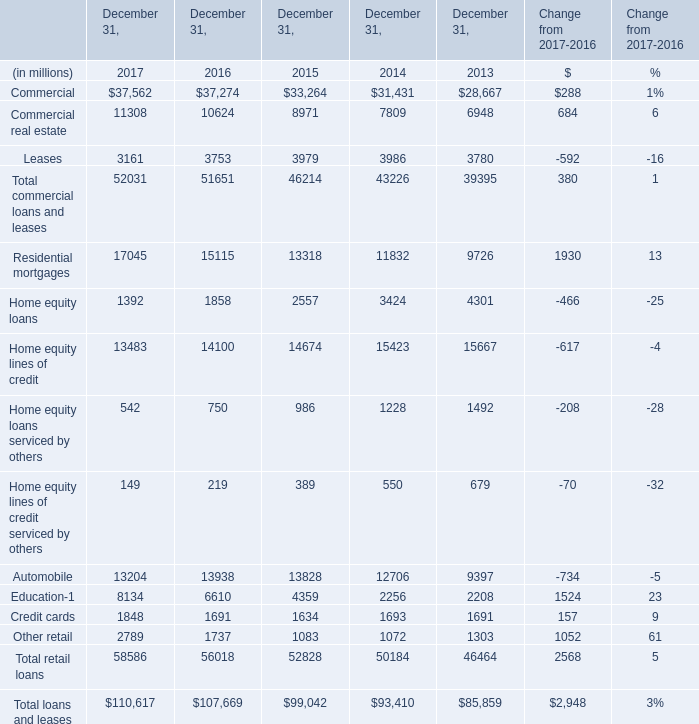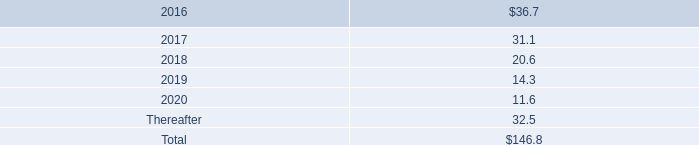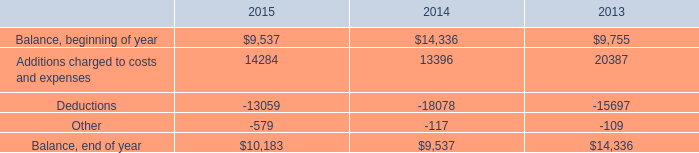what's the total amount of Balance, end of year of 2014, and Leases of December 31, 2015 ? 
Computations: (9537.0 + 3979.0)
Answer: 13516.0. 